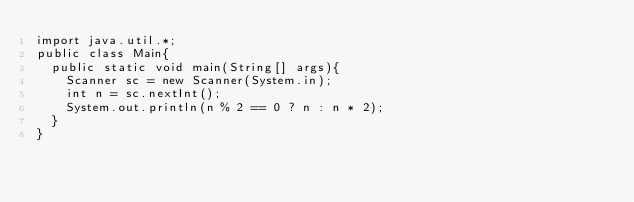Convert code to text. <code><loc_0><loc_0><loc_500><loc_500><_Java_>import java.util.*;
public class Main{
  public static void main(String[] args){
    Scanner sc = new Scanner(System.in);
    int n = sc.nextInt();
    System.out.println(n % 2 == 0 ? n : n * 2);
  }
}</code> 